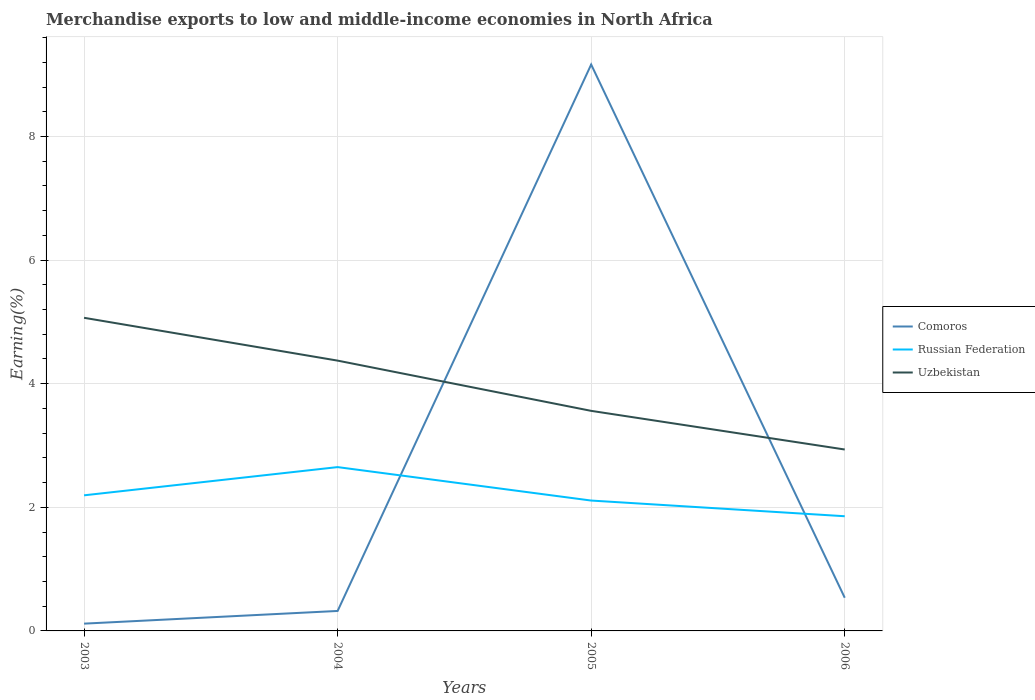Does the line corresponding to Uzbekistan intersect with the line corresponding to Russian Federation?
Your response must be concise. No. Is the number of lines equal to the number of legend labels?
Your answer should be compact. Yes. Across all years, what is the maximum percentage of amount earned from merchandise exports in Comoros?
Provide a short and direct response. 0.12. In which year was the percentage of amount earned from merchandise exports in Uzbekistan maximum?
Ensure brevity in your answer.  2006. What is the total percentage of amount earned from merchandise exports in Uzbekistan in the graph?
Your answer should be compact. 2.13. What is the difference between the highest and the second highest percentage of amount earned from merchandise exports in Russian Federation?
Your response must be concise. 0.79. What is the difference between the highest and the lowest percentage of amount earned from merchandise exports in Russian Federation?
Provide a short and direct response. 1. How many years are there in the graph?
Ensure brevity in your answer.  4. Does the graph contain grids?
Your answer should be compact. Yes. How many legend labels are there?
Keep it short and to the point. 3. What is the title of the graph?
Your answer should be compact. Merchandise exports to low and middle-income economies in North Africa. What is the label or title of the X-axis?
Your answer should be compact. Years. What is the label or title of the Y-axis?
Ensure brevity in your answer.  Earning(%). What is the Earning(%) in Comoros in 2003?
Your answer should be very brief. 0.12. What is the Earning(%) in Russian Federation in 2003?
Ensure brevity in your answer.  2.19. What is the Earning(%) in Uzbekistan in 2003?
Your answer should be compact. 5.07. What is the Earning(%) of Comoros in 2004?
Ensure brevity in your answer.  0.32. What is the Earning(%) of Russian Federation in 2004?
Offer a terse response. 2.65. What is the Earning(%) in Uzbekistan in 2004?
Ensure brevity in your answer.  4.37. What is the Earning(%) in Comoros in 2005?
Offer a very short reply. 9.16. What is the Earning(%) of Russian Federation in 2005?
Make the answer very short. 2.11. What is the Earning(%) in Uzbekistan in 2005?
Offer a terse response. 3.56. What is the Earning(%) of Comoros in 2006?
Offer a terse response. 0.54. What is the Earning(%) in Russian Federation in 2006?
Offer a terse response. 1.86. What is the Earning(%) in Uzbekistan in 2006?
Your answer should be compact. 2.94. Across all years, what is the maximum Earning(%) in Comoros?
Provide a short and direct response. 9.16. Across all years, what is the maximum Earning(%) in Russian Federation?
Your response must be concise. 2.65. Across all years, what is the maximum Earning(%) in Uzbekistan?
Give a very brief answer. 5.07. Across all years, what is the minimum Earning(%) in Comoros?
Provide a short and direct response. 0.12. Across all years, what is the minimum Earning(%) in Russian Federation?
Your answer should be very brief. 1.86. Across all years, what is the minimum Earning(%) of Uzbekistan?
Keep it short and to the point. 2.94. What is the total Earning(%) of Comoros in the graph?
Offer a very short reply. 10.14. What is the total Earning(%) of Russian Federation in the graph?
Make the answer very short. 8.81. What is the total Earning(%) in Uzbekistan in the graph?
Your answer should be compact. 15.94. What is the difference between the Earning(%) in Comoros in 2003 and that in 2004?
Offer a terse response. -0.21. What is the difference between the Earning(%) in Russian Federation in 2003 and that in 2004?
Keep it short and to the point. -0.46. What is the difference between the Earning(%) of Uzbekistan in 2003 and that in 2004?
Offer a very short reply. 0.69. What is the difference between the Earning(%) of Comoros in 2003 and that in 2005?
Give a very brief answer. -9.05. What is the difference between the Earning(%) of Russian Federation in 2003 and that in 2005?
Provide a short and direct response. 0.08. What is the difference between the Earning(%) in Uzbekistan in 2003 and that in 2005?
Your answer should be very brief. 1.51. What is the difference between the Earning(%) in Comoros in 2003 and that in 2006?
Your response must be concise. -0.42. What is the difference between the Earning(%) of Russian Federation in 2003 and that in 2006?
Provide a succinct answer. 0.34. What is the difference between the Earning(%) of Uzbekistan in 2003 and that in 2006?
Ensure brevity in your answer.  2.13. What is the difference between the Earning(%) of Comoros in 2004 and that in 2005?
Keep it short and to the point. -8.84. What is the difference between the Earning(%) in Russian Federation in 2004 and that in 2005?
Offer a very short reply. 0.54. What is the difference between the Earning(%) of Uzbekistan in 2004 and that in 2005?
Keep it short and to the point. 0.81. What is the difference between the Earning(%) of Comoros in 2004 and that in 2006?
Your answer should be compact. -0.21. What is the difference between the Earning(%) of Russian Federation in 2004 and that in 2006?
Make the answer very short. 0.8. What is the difference between the Earning(%) in Uzbekistan in 2004 and that in 2006?
Your answer should be very brief. 1.44. What is the difference between the Earning(%) of Comoros in 2005 and that in 2006?
Keep it short and to the point. 8.63. What is the difference between the Earning(%) of Russian Federation in 2005 and that in 2006?
Your answer should be compact. 0.25. What is the difference between the Earning(%) of Uzbekistan in 2005 and that in 2006?
Your answer should be very brief. 0.63. What is the difference between the Earning(%) in Comoros in 2003 and the Earning(%) in Russian Federation in 2004?
Ensure brevity in your answer.  -2.53. What is the difference between the Earning(%) in Comoros in 2003 and the Earning(%) in Uzbekistan in 2004?
Provide a short and direct response. -4.26. What is the difference between the Earning(%) of Russian Federation in 2003 and the Earning(%) of Uzbekistan in 2004?
Provide a short and direct response. -2.18. What is the difference between the Earning(%) in Comoros in 2003 and the Earning(%) in Russian Federation in 2005?
Provide a succinct answer. -1.99. What is the difference between the Earning(%) in Comoros in 2003 and the Earning(%) in Uzbekistan in 2005?
Your answer should be very brief. -3.44. What is the difference between the Earning(%) of Russian Federation in 2003 and the Earning(%) of Uzbekistan in 2005?
Make the answer very short. -1.37. What is the difference between the Earning(%) of Comoros in 2003 and the Earning(%) of Russian Federation in 2006?
Your response must be concise. -1.74. What is the difference between the Earning(%) in Comoros in 2003 and the Earning(%) in Uzbekistan in 2006?
Ensure brevity in your answer.  -2.82. What is the difference between the Earning(%) of Russian Federation in 2003 and the Earning(%) of Uzbekistan in 2006?
Ensure brevity in your answer.  -0.74. What is the difference between the Earning(%) in Comoros in 2004 and the Earning(%) in Russian Federation in 2005?
Offer a terse response. -1.79. What is the difference between the Earning(%) in Comoros in 2004 and the Earning(%) in Uzbekistan in 2005?
Provide a succinct answer. -3.24. What is the difference between the Earning(%) of Russian Federation in 2004 and the Earning(%) of Uzbekistan in 2005?
Make the answer very short. -0.91. What is the difference between the Earning(%) of Comoros in 2004 and the Earning(%) of Russian Federation in 2006?
Offer a very short reply. -1.53. What is the difference between the Earning(%) in Comoros in 2004 and the Earning(%) in Uzbekistan in 2006?
Your response must be concise. -2.61. What is the difference between the Earning(%) of Russian Federation in 2004 and the Earning(%) of Uzbekistan in 2006?
Keep it short and to the point. -0.28. What is the difference between the Earning(%) of Comoros in 2005 and the Earning(%) of Russian Federation in 2006?
Offer a terse response. 7.31. What is the difference between the Earning(%) in Comoros in 2005 and the Earning(%) in Uzbekistan in 2006?
Ensure brevity in your answer.  6.23. What is the difference between the Earning(%) in Russian Federation in 2005 and the Earning(%) in Uzbekistan in 2006?
Provide a short and direct response. -0.83. What is the average Earning(%) in Comoros per year?
Give a very brief answer. 2.54. What is the average Earning(%) in Russian Federation per year?
Your answer should be compact. 2.2. What is the average Earning(%) in Uzbekistan per year?
Make the answer very short. 3.98. In the year 2003, what is the difference between the Earning(%) in Comoros and Earning(%) in Russian Federation?
Offer a terse response. -2.08. In the year 2003, what is the difference between the Earning(%) in Comoros and Earning(%) in Uzbekistan?
Offer a terse response. -4.95. In the year 2003, what is the difference between the Earning(%) in Russian Federation and Earning(%) in Uzbekistan?
Provide a short and direct response. -2.87. In the year 2004, what is the difference between the Earning(%) of Comoros and Earning(%) of Russian Federation?
Your answer should be compact. -2.33. In the year 2004, what is the difference between the Earning(%) in Comoros and Earning(%) in Uzbekistan?
Provide a short and direct response. -4.05. In the year 2004, what is the difference between the Earning(%) in Russian Federation and Earning(%) in Uzbekistan?
Offer a terse response. -1.72. In the year 2005, what is the difference between the Earning(%) of Comoros and Earning(%) of Russian Federation?
Keep it short and to the point. 7.06. In the year 2005, what is the difference between the Earning(%) in Comoros and Earning(%) in Uzbekistan?
Provide a short and direct response. 5.6. In the year 2005, what is the difference between the Earning(%) of Russian Federation and Earning(%) of Uzbekistan?
Offer a very short reply. -1.45. In the year 2006, what is the difference between the Earning(%) in Comoros and Earning(%) in Russian Federation?
Keep it short and to the point. -1.32. In the year 2006, what is the difference between the Earning(%) of Comoros and Earning(%) of Uzbekistan?
Your answer should be very brief. -2.4. In the year 2006, what is the difference between the Earning(%) in Russian Federation and Earning(%) in Uzbekistan?
Your response must be concise. -1.08. What is the ratio of the Earning(%) in Comoros in 2003 to that in 2004?
Ensure brevity in your answer.  0.36. What is the ratio of the Earning(%) of Russian Federation in 2003 to that in 2004?
Offer a very short reply. 0.83. What is the ratio of the Earning(%) of Uzbekistan in 2003 to that in 2004?
Provide a succinct answer. 1.16. What is the ratio of the Earning(%) of Comoros in 2003 to that in 2005?
Keep it short and to the point. 0.01. What is the ratio of the Earning(%) of Russian Federation in 2003 to that in 2005?
Offer a very short reply. 1.04. What is the ratio of the Earning(%) of Uzbekistan in 2003 to that in 2005?
Give a very brief answer. 1.42. What is the ratio of the Earning(%) in Comoros in 2003 to that in 2006?
Keep it short and to the point. 0.22. What is the ratio of the Earning(%) in Russian Federation in 2003 to that in 2006?
Make the answer very short. 1.18. What is the ratio of the Earning(%) in Uzbekistan in 2003 to that in 2006?
Keep it short and to the point. 1.73. What is the ratio of the Earning(%) of Comoros in 2004 to that in 2005?
Keep it short and to the point. 0.04. What is the ratio of the Earning(%) in Russian Federation in 2004 to that in 2005?
Your answer should be very brief. 1.26. What is the ratio of the Earning(%) of Uzbekistan in 2004 to that in 2005?
Your answer should be very brief. 1.23. What is the ratio of the Earning(%) in Comoros in 2004 to that in 2006?
Offer a very short reply. 0.6. What is the ratio of the Earning(%) in Russian Federation in 2004 to that in 2006?
Your response must be concise. 1.43. What is the ratio of the Earning(%) of Uzbekistan in 2004 to that in 2006?
Provide a short and direct response. 1.49. What is the ratio of the Earning(%) of Comoros in 2005 to that in 2006?
Offer a terse response. 17.07. What is the ratio of the Earning(%) of Russian Federation in 2005 to that in 2006?
Give a very brief answer. 1.14. What is the ratio of the Earning(%) in Uzbekistan in 2005 to that in 2006?
Your response must be concise. 1.21. What is the difference between the highest and the second highest Earning(%) of Comoros?
Ensure brevity in your answer.  8.63. What is the difference between the highest and the second highest Earning(%) of Russian Federation?
Offer a very short reply. 0.46. What is the difference between the highest and the second highest Earning(%) in Uzbekistan?
Your response must be concise. 0.69. What is the difference between the highest and the lowest Earning(%) in Comoros?
Your answer should be very brief. 9.05. What is the difference between the highest and the lowest Earning(%) of Russian Federation?
Your answer should be compact. 0.8. What is the difference between the highest and the lowest Earning(%) in Uzbekistan?
Make the answer very short. 2.13. 